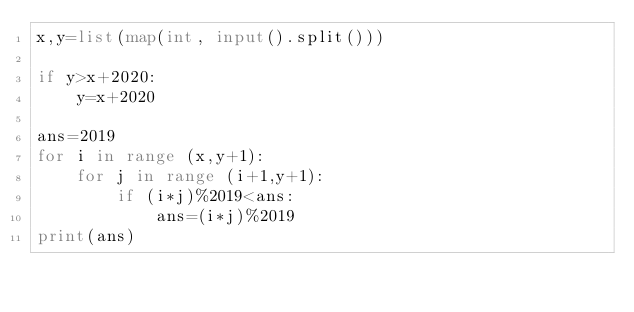<code> <loc_0><loc_0><loc_500><loc_500><_Python_>x,y=list(map(int, input().split()))

if y>x+2020:
	y=x+2020

ans=2019
for i in range (x,y+1):
	for j in range (i+1,y+1):
		if (i*j)%2019<ans:
			ans=(i*j)%2019
print(ans)</code> 